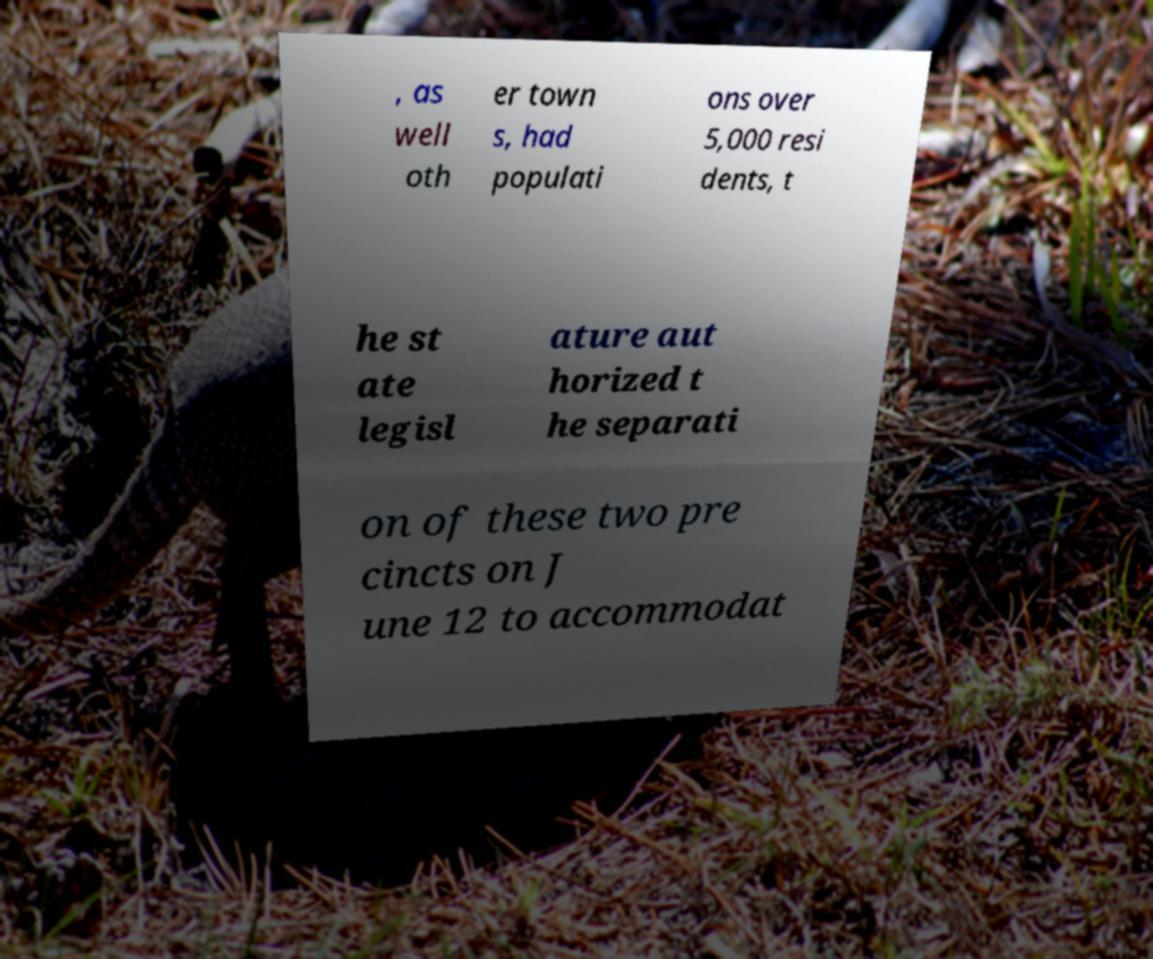Could you assist in decoding the text presented in this image and type it out clearly? , as well oth er town s, had populati ons over 5,000 resi dents, t he st ate legisl ature aut horized t he separati on of these two pre cincts on J une 12 to accommodat 